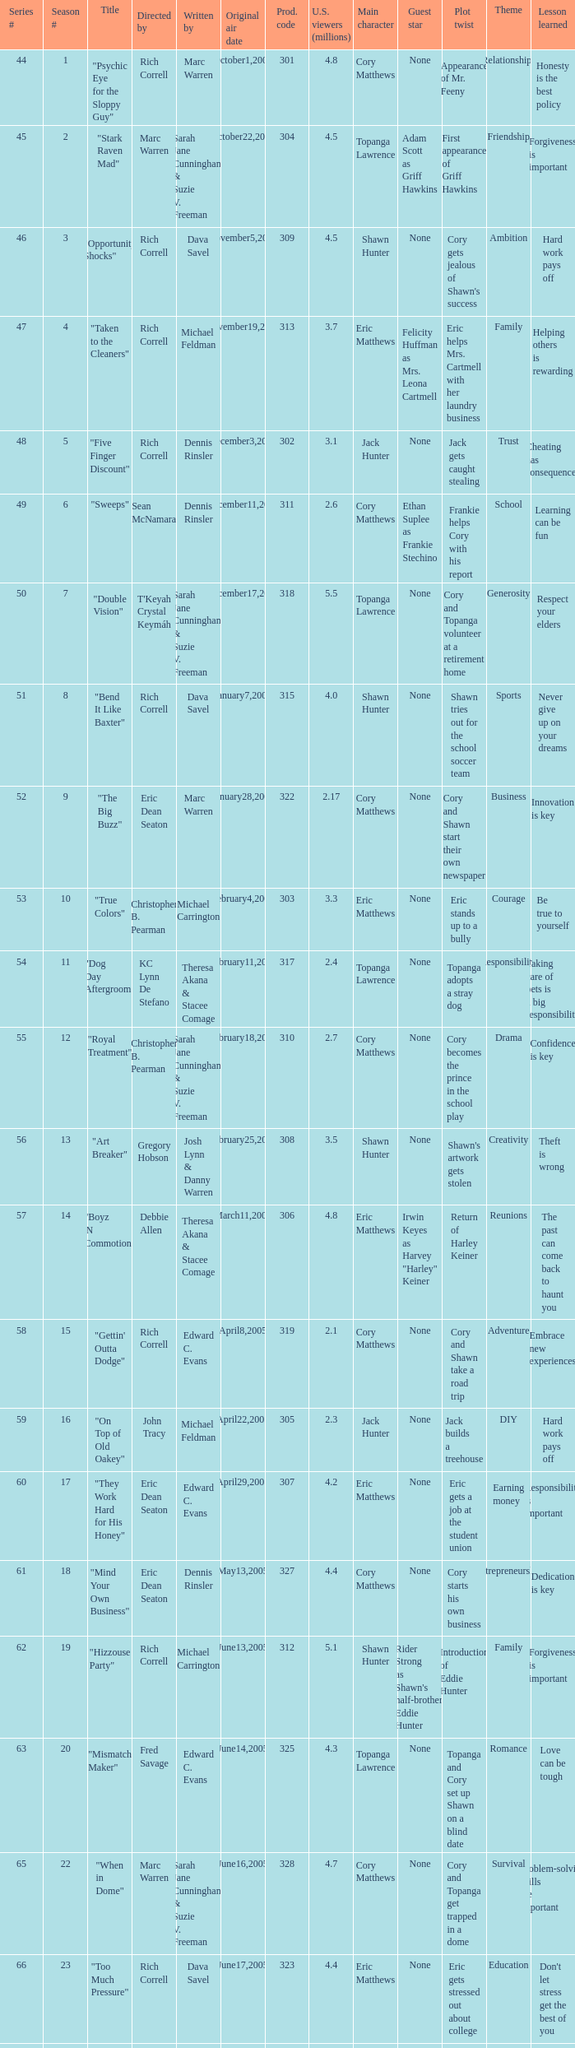What was the production code of the episode directed by Rondell Sheridan?  332.0. 